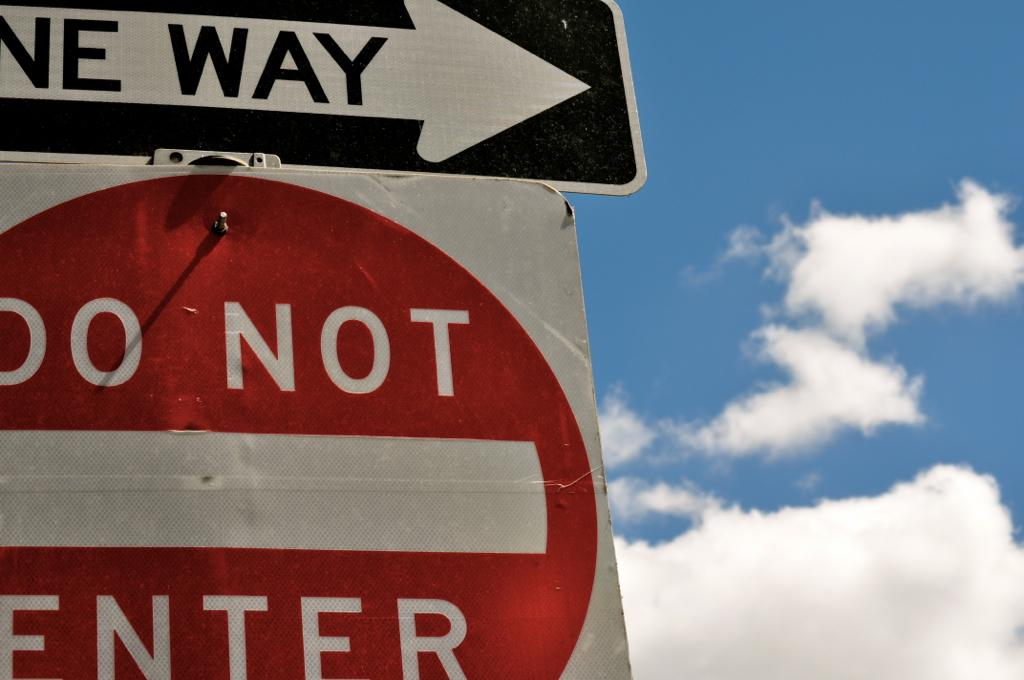<image>
Create a compact narrative representing the image presented. A One Way sign points the way above a red and white Do Not Enter sign. 